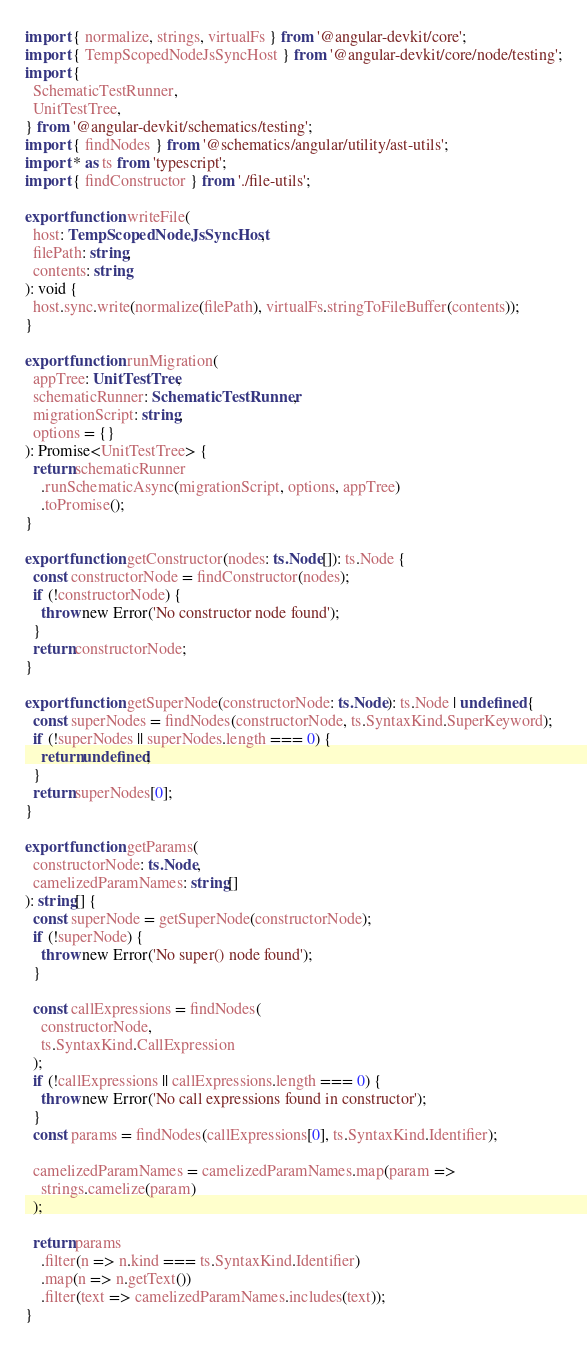Convert code to text. <code><loc_0><loc_0><loc_500><loc_500><_TypeScript_>import { normalize, strings, virtualFs } from '@angular-devkit/core';
import { TempScopedNodeJsSyncHost } from '@angular-devkit/core/node/testing';
import {
  SchematicTestRunner,
  UnitTestTree,
} from '@angular-devkit/schematics/testing';
import { findNodes } from '@schematics/angular/utility/ast-utils';
import * as ts from 'typescript';
import { findConstructor } from './file-utils';

export function writeFile(
  host: TempScopedNodeJsSyncHost,
  filePath: string,
  contents: string
): void {
  host.sync.write(normalize(filePath), virtualFs.stringToFileBuffer(contents));
}

export function runMigration(
  appTree: UnitTestTree,
  schematicRunner: SchematicTestRunner,
  migrationScript: string,
  options = {}
): Promise<UnitTestTree> {
  return schematicRunner
    .runSchematicAsync(migrationScript, options, appTree)
    .toPromise();
}

export function getConstructor(nodes: ts.Node[]): ts.Node {
  const constructorNode = findConstructor(nodes);
  if (!constructorNode) {
    throw new Error('No constructor node found');
  }
  return constructorNode;
}

export function getSuperNode(constructorNode: ts.Node): ts.Node | undefined {
  const superNodes = findNodes(constructorNode, ts.SyntaxKind.SuperKeyword);
  if (!superNodes || superNodes.length === 0) {
    return undefined;
  }
  return superNodes[0];
}

export function getParams(
  constructorNode: ts.Node,
  camelizedParamNames: string[]
): string[] {
  const superNode = getSuperNode(constructorNode);
  if (!superNode) {
    throw new Error('No super() node found');
  }

  const callExpressions = findNodes(
    constructorNode,
    ts.SyntaxKind.CallExpression
  );
  if (!callExpressions || callExpressions.length === 0) {
    throw new Error('No call expressions found in constructor');
  }
  const params = findNodes(callExpressions[0], ts.SyntaxKind.Identifier);

  camelizedParamNames = camelizedParamNames.map(param =>
    strings.camelize(param)
  );

  return params
    .filter(n => n.kind === ts.SyntaxKind.Identifier)
    .map(n => n.getText())
    .filter(text => camelizedParamNames.includes(text));
}
</code> 